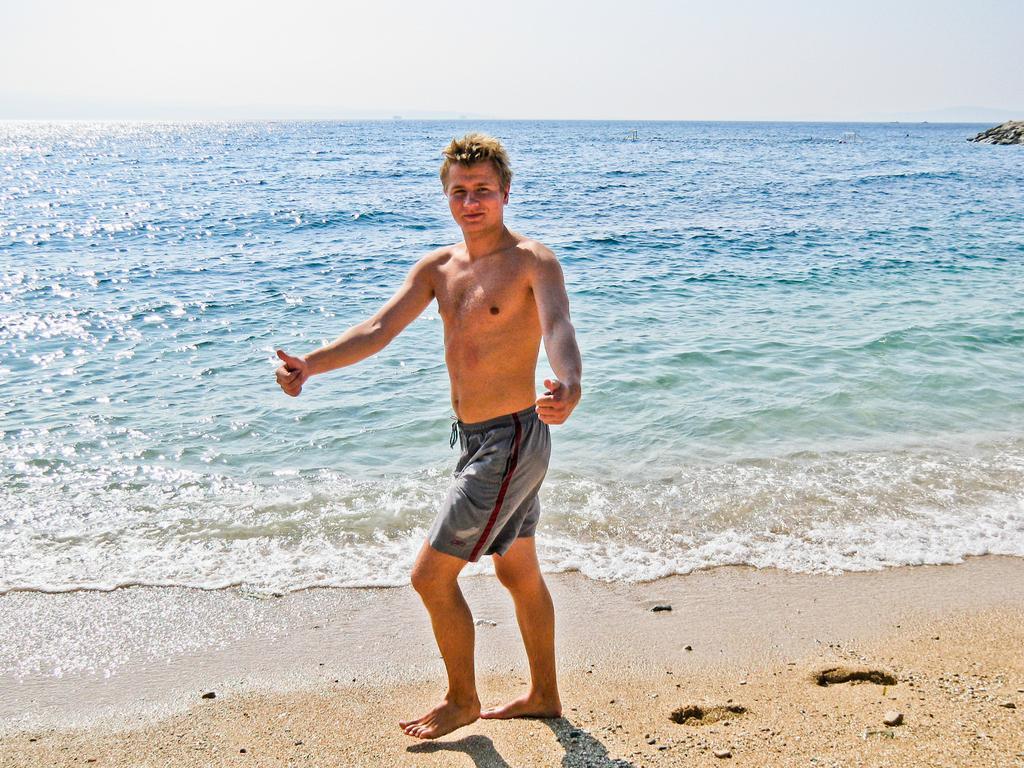Can you describe this image briefly? In this image in the front there is a person standing. In the background there is an ocean. On the right side there are stones. 